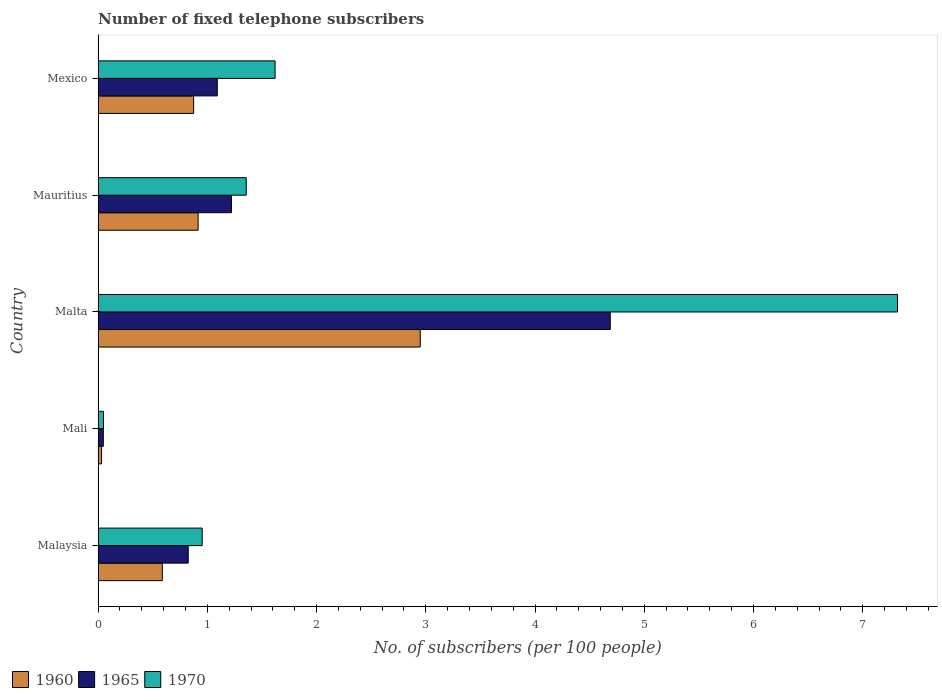Are the number of bars on each tick of the Y-axis equal?
Offer a terse response. Yes. How many bars are there on the 2nd tick from the top?
Make the answer very short. 3. How many bars are there on the 4th tick from the bottom?
Keep it short and to the point. 3. What is the label of the 3rd group of bars from the top?
Give a very brief answer. Malta. In how many cases, is the number of bars for a given country not equal to the number of legend labels?
Offer a terse response. 0. What is the number of fixed telephone subscribers in 1970 in Mauritius?
Offer a very short reply. 1.36. Across all countries, what is the maximum number of fixed telephone subscribers in 1970?
Offer a terse response. 7.32. Across all countries, what is the minimum number of fixed telephone subscribers in 1965?
Keep it short and to the point. 0.05. In which country was the number of fixed telephone subscribers in 1960 maximum?
Make the answer very short. Malta. In which country was the number of fixed telephone subscribers in 1970 minimum?
Your answer should be very brief. Mali. What is the total number of fixed telephone subscribers in 1965 in the graph?
Offer a terse response. 7.88. What is the difference between the number of fixed telephone subscribers in 1960 in Mali and that in Mauritius?
Offer a very short reply. -0.88. What is the difference between the number of fixed telephone subscribers in 1960 in Malaysia and the number of fixed telephone subscribers in 1965 in Mali?
Provide a short and direct response. 0.54. What is the average number of fixed telephone subscribers in 1960 per country?
Keep it short and to the point. 1.07. What is the difference between the number of fixed telephone subscribers in 1965 and number of fixed telephone subscribers in 1960 in Mexico?
Your answer should be very brief. 0.22. In how many countries, is the number of fixed telephone subscribers in 1965 greater than 3.2 ?
Ensure brevity in your answer.  1. What is the ratio of the number of fixed telephone subscribers in 1970 in Malaysia to that in Mali?
Make the answer very short. 19.1. Is the number of fixed telephone subscribers in 1965 in Mali less than that in Mexico?
Your response must be concise. Yes. What is the difference between the highest and the second highest number of fixed telephone subscribers in 1970?
Provide a short and direct response. 5.7. What is the difference between the highest and the lowest number of fixed telephone subscribers in 1970?
Keep it short and to the point. 7.27. What does the 1st bar from the bottom in Malaysia represents?
Make the answer very short. 1960. Is it the case that in every country, the sum of the number of fixed telephone subscribers in 1965 and number of fixed telephone subscribers in 1960 is greater than the number of fixed telephone subscribers in 1970?
Give a very brief answer. Yes. Are all the bars in the graph horizontal?
Your response must be concise. Yes. How many countries are there in the graph?
Make the answer very short. 5. What is the difference between two consecutive major ticks on the X-axis?
Keep it short and to the point. 1. Are the values on the major ticks of X-axis written in scientific E-notation?
Your answer should be very brief. No. Where does the legend appear in the graph?
Your answer should be very brief. Bottom left. What is the title of the graph?
Keep it short and to the point. Number of fixed telephone subscribers. Does "1989" appear as one of the legend labels in the graph?
Keep it short and to the point. No. What is the label or title of the X-axis?
Your answer should be compact. No. of subscribers (per 100 people). What is the label or title of the Y-axis?
Your response must be concise. Country. What is the No. of subscribers (per 100 people) in 1960 in Malaysia?
Give a very brief answer. 0.59. What is the No. of subscribers (per 100 people) in 1965 in Malaysia?
Offer a terse response. 0.83. What is the No. of subscribers (per 100 people) in 1970 in Malaysia?
Give a very brief answer. 0.95. What is the No. of subscribers (per 100 people) in 1960 in Mali?
Provide a short and direct response. 0.03. What is the No. of subscribers (per 100 people) in 1965 in Mali?
Make the answer very short. 0.05. What is the No. of subscribers (per 100 people) in 1970 in Mali?
Offer a very short reply. 0.05. What is the No. of subscribers (per 100 people) of 1960 in Malta?
Offer a very short reply. 2.95. What is the No. of subscribers (per 100 people) of 1965 in Malta?
Offer a very short reply. 4.69. What is the No. of subscribers (per 100 people) of 1970 in Malta?
Provide a short and direct response. 7.32. What is the No. of subscribers (per 100 people) in 1960 in Mauritius?
Your response must be concise. 0.92. What is the No. of subscribers (per 100 people) of 1965 in Mauritius?
Keep it short and to the point. 1.22. What is the No. of subscribers (per 100 people) of 1970 in Mauritius?
Your response must be concise. 1.36. What is the No. of subscribers (per 100 people) of 1960 in Mexico?
Your answer should be compact. 0.88. What is the No. of subscribers (per 100 people) of 1965 in Mexico?
Keep it short and to the point. 1.09. What is the No. of subscribers (per 100 people) in 1970 in Mexico?
Provide a succinct answer. 1.62. Across all countries, what is the maximum No. of subscribers (per 100 people) of 1960?
Provide a succinct answer. 2.95. Across all countries, what is the maximum No. of subscribers (per 100 people) in 1965?
Offer a terse response. 4.69. Across all countries, what is the maximum No. of subscribers (per 100 people) in 1970?
Offer a terse response. 7.32. Across all countries, what is the minimum No. of subscribers (per 100 people) of 1960?
Provide a short and direct response. 0.03. Across all countries, what is the minimum No. of subscribers (per 100 people) of 1965?
Make the answer very short. 0.05. Across all countries, what is the minimum No. of subscribers (per 100 people) in 1970?
Offer a very short reply. 0.05. What is the total No. of subscribers (per 100 people) in 1960 in the graph?
Keep it short and to the point. 5.36. What is the total No. of subscribers (per 100 people) in 1965 in the graph?
Your answer should be very brief. 7.88. What is the total No. of subscribers (per 100 people) in 1970 in the graph?
Provide a succinct answer. 11.3. What is the difference between the No. of subscribers (per 100 people) in 1960 in Malaysia and that in Mali?
Give a very brief answer. 0.56. What is the difference between the No. of subscribers (per 100 people) of 1965 in Malaysia and that in Mali?
Your answer should be very brief. 0.78. What is the difference between the No. of subscribers (per 100 people) of 1970 in Malaysia and that in Mali?
Offer a very short reply. 0.9. What is the difference between the No. of subscribers (per 100 people) of 1960 in Malaysia and that in Malta?
Give a very brief answer. -2.36. What is the difference between the No. of subscribers (per 100 people) of 1965 in Malaysia and that in Malta?
Provide a succinct answer. -3.86. What is the difference between the No. of subscribers (per 100 people) in 1970 in Malaysia and that in Malta?
Your answer should be very brief. -6.36. What is the difference between the No. of subscribers (per 100 people) in 1960 in Malaysia and that in Mauritius?
Keep it short and to the point. -0.33. What is the difference between the No. of subscribers (per 100 people) in 1965 in Malaysia and that in Mauritius?
Provide a short and direct response. -0.4. What is the difference between the No. of subscribers (per 100 people) of 1970 in Malaysia and that in Mauritius?
Ensure brevity in your answer.  -0.4. What is the difference between the No. of subscribers (per 100 people) in 1960 in Malaysia and that in Mexico?
Provide a short and direct response. -0.29. What is the difference between the No. of subscribers (per 100 people) in 1965 in Malaysia and that in Mexico?
Offer a very short reply. -0.27. What is the difference between the No. of subscribers (per 100 people) in 1970 in Malaysia and that in Mexico?
Offer a very short reply. -0.67. What is the difference between the No. of subscribers (per 100 people) in 1960 in Mali and that in Malta?
Give a very brief answer. -2.92. What is the difference between the No. of subscribers (per 100 people) of 1965 in Mali and that in Malta?
Keep it short and to the point. -4.64. What is the difference between the No. of subscribers (per 100 people) in 1970 in Mali and that in Malta?
Offer a very short reply. -7.27. What is the difference between the No. of subscribers (per 100 people) in 1960 in Mali and that in Mauritius?
Make the answer very short. -0.88. What is the difference between the No. of subscribers (per 100 people) of 1965 in Mali and that in Mauritius?
Ensure brevity in your answer.  -1.17. What is the difference between the No. of subscribers (per 100 people) of 1970 in Mali and that in Mauritius?
Offer a very short reply. -1.31. What is the difference between the No. of subscribers (per 100 people) in 1960 in Mali and that in Mexico?
Your answer should be compact. -0.84. What is the difference between the No. of subscribers (per 100 people) of 1965 in Mali and that in Mexico?
Offer a very short reply. -1.04. What is the difference between the No. of subscribers (per 100 people) in 1970 in Mali and that in Mexico?
Provide a succinct answer. -1.57. What is the difference between the No. of subscribers (per 100 people) in 1960 in Malta and that in Mauritius?
Make the answer very short. 2.03. What is the difference between the No. of subscribers (per 100 people) of 1965 in Malta and that in Mauritius?
Ensure brevity in your answer.  3.47. What is the difference between the No. of subscribers (per 100 people) of 1970 in Malta and that in Mauritius?
Ensure brevity in your answer.  5.96. What is the difference between the No. of subscribers (per 100 people) in 1960 in Malta and that in Mexico?
Your answer should be compact. 2.07. What is the difference between the No. of subscribers (per 100 people) in 1965 in Malta and that in Mexico?
Your answer should be very brief. 3.6. What is the difference between the No. of subscribers (per 100 people) in 1970 in Malta and that in Mexico?
Offer a very short reply. 5.7. What is the difference between the No. of subscribers (per 100 people) in 1960 in Mauritius and that in Mexico?
Keep it short and to the point. 0.04. What is the difference between the No. of subscribers (per 100 people) in 1965 in Mauritius and that in Mexico?
Your answer should be very brief. 0.13. What is the difference between the No. of subscribers (per 100 people) in 1970 in Mauritius and that in Mexico?
Your answer should be very brief. -0.26. What is the difference between the No. of subscribers (per 100 people) of 1960 in Malaysia and the No. of subscribers (per 100 people) of 1965 in Mali?
Offer a terse response. 0.54. What is the difference between the No. of subscribers (per 100 people) in 1960 in Malaysia and the No. of subscribers (per 100 people) in 1970 in Mali?
Provide a short and direct response. 0.54. What is the difference between the No. of subscribers (per 100 people) in 1965 in Malaysia and the No. of subscribers (per 100 people) in 1970 in Mali?
Keep it short and to the point. 0.78. What is the difference between the No. of subscribers (per 100 people) in 1960 in Malaysia and the No. of subscribers (per 100 people) in 1965 in Malta?
Ensure brevity in your answer.  -4.1. What is the difference between the No. of subscribers (per 100 people) in 1960 in Malaysia and the No. of subscribers (per 100 people) in 1970 in Malta?
Your answer should be very brief. -6.73. What is the difference between the No. of subscribers (per 100 people) in 1965 in Malaysia and the No. of subscribers (per 100 people) in 1970 in Malta?
Offer a very short reply. -6.49. What is the difference between the No. of subscribers (per 100 people) in 1960 in Malaysia and the No. of subscribers (per 100 people) in 1965 in Mauritius?
Your response must be concise. -0.63. What is the difference between the No. of subscribers (per 100 people) in 1960 in Malaysia and the No. of subscribers (per 100 people) in 1970 in Mauritius?
Offer a very short reply. -0.77. What is the difference between the No. of subscribers (per 100 people) of 1965 in Malaysia and the No. of subscribers (per 100 people) of 1970 in Mauritius?
Your response must be concise. -0.53. What is the difference between the No. of subscribers (per 100 people) of 1960 in Malaysia and the No. of subscribers (per 100 people) of 1965 in Mexico?
Your answer should be compact. -0.5. What is the difference between the No. of subscribers (per 100 people) in 1960 in Malaysia and the No. of subscribers (per 100 people) in 1970 in Mexico?
Give a very brief answer. -1.03. What is the difference between the No. of subscribers (per 100 people) in 1965 in Malaysia and the No. of subscribers (per 100 people) in 1970 in Mexico?
Provide a short and direct response. -0.8. What is the difference between the No. of subscribers (per 100 people) of 1960 in Mali and the No. of subscribers (per 100 people) of 1965 in Malta?
Offer a very short reply. -4.66. What is the difference between the No. of subscribers (per 100 people) in 1960 in Mali and the No. of subscribers (per 100 people) in 1970 in Malta?
Offer a very short reply. -7.29. What is the difference between the No. of subscribers (per 100 people) of 1965 in Mali and the No. of subscribers (per 100 people) of 1970 in Malta?
Provide a succinct answer. -7.27. What is the difference between the No. of subscribers (per 100 people) of 1960 in Mali and the No. of subscribers (per 100 people) of 1965 in Mauritius?
Give a very brief answer. -1.19. What is the difference between the No. of subscribers (per 100 people) of 1960 in Mali and the No. of subscribers (per 100 people) of 1970 in Mauritius?
Ensure brevity in your answer.  -1.32. What is the difference between the No. of subscribers (per 100 people) in 1965 in Mali and the No. of subscribers (per 100 people) in 1970 in Mauritius?
Make the answer very short. -1.31. What is the difference between the No. of subscribers (per 100 people) of 1960 in Mali and the No. of subscribers (per 100 people) of 1965 in Mexico?
Make the answer very short. -1.06. What is the difference between the No. of subscribers (per 100 people) of 1960 in Mali and the No. of subscribers (per 100 people) of 1970 in Mexico?
Provide a succinct answer. -1.59. What is the difference between the No. of subscribers (per 100 people) of 1965 in Mali and the No. of subscribers (per 100 people) of 1970 in Mexico?
Your response must be concise. -1.57. What is the difference between the No. of subscribers (per 100 people) in 1960 in Malta and the No. of subscribers (per 100 people) in 1965 in Mauritius?
Provide a succinct answer. 1.73. What is the difference between the No. of subscribers (per 100 people) in 1960 in Malta and the No. of subscribers (per 100 people) in 1970 in Mauritius?
Give a very brief answer. 1.59. What is the difference between the No. of subscribers (per 100 people) of 1965 in Malta and the No. of subscribers (per 100 people) of 1970 in Mauritius?
Make the answer very short. 3.33. What is the difference between the No. of subscribers (per 100 people) in 1960 in Malta and the No. of subscribers (per 100 people) in 1965 in Mexico?
Your answer should be compact. 1.86. What is the difference between the No. of subscribers (per 100 people) of 1960 in Malta and the No. of subscribers (per 100 people) of 1970 in Mexico?
Offer a terse response. 1.33. What is the difference between the No. of subscribers (per 100 people) in 1965 in Malta and the No. of subscribers (per 100 people) in 1970 in Mexico?
Your answer should be very brief. 3.07. What is the difference between the No. of subscribers (per 100 people) in 1960 in Mauritius and the No. of subscribers (per 100 people) in 1965 in Mexico?
Your answer should be very brief. -0.18. What is the difference between the No. of subscribers (per 100 people) of 1960 in Mauritius and the No. of subscribers (per 100 people) of 1970 in Mexico?
Your response must be concise. -0.7. What is the difference between the No. of subscribers (per 100 people) in 1965 in Mauritius and the No. of subscribers (per 100 people) in 1970 in Mexico?
Provide a short and direct response. -0.4. What is the average No. of subscribers (per 100 people) in 1960 per country?
Ensure brevity in your answer.  1.07. What is the average No. of subscribers (per 100 people) of 1965 per country?
Give a very brief answer. 1.58. What is the average No. of subscribers (per 100 people) of 1970 per country?
Your response must be concise. 2.26. What is the difference between the No. of subscribers (per 100 people) in 1960 and No. of subscribers (per 100 people) in 1965 in Malaysia?
Keep it short and to the point. -0.24. What is the difference between the No. of subscribers (per 100 people) in 1960 and No. of subscribers (per 100 people) in 1970 in Malaysia?
Provide a succinct answer. -0.36. What is the difference between the No. of subscribers (per 100 people) of 1965 and No. of subscribers (per 100 people) of 1970 in Malaysia?
Keep it short and to the point. -0.13. What is the difference between the No. of subscribers (per 100 people) in 1960 and No. of subscribers (per 100 people) in 1965 in Mali?
Give a very brief answer. -0.02. What is the difference between the No. of subscribers (per 100 people) in 1960 and No. of subscribers (per 100 people) in 1970 in Mali?
Make the answer very short. -0.02. What is the difference between the No. of subscribers (per 100 people) in 1965 and No. of subscribers (per 100 people) in 1970 in Mali?
Provide a succinct answer. -0. What is the difference between the No. of subscribers (per 100 people) in 1960 and No. of subscribers (per 100 people) in 1965 in Malta?
Keep it short and to the point. -1.74. What is the difference between the No. of subscribers (per 100 people) of 1960 and No. of subscribers (per 100 people) of 1970 in Malta?
Offer a very short reply. -4.37. What is the difference between the No. of subscribers (per 100 people) in 1965 and No. of subscribers (per 100 people) in 1970 in Malta?
Provide a short and direct response. -2.63. What is the difference between the No. of subscribers (per 100 people) of 1960 and No. of subscribers (per 100 people) of 1965 in Mauritius?
Offer a very short reply. -0.31. What is the difference between the No. of subscribers (per 100 people) in 1960 and No. of subscribers (per 100 people) in 1970 in Mauritius?
Keep it short and to the point. -0.44. What is the difference between the No. of subscribers (per 100 people) in 1965 and No. of subscribers (per 100 people) in 1970 in Mauritius?
Ensure brevity in your answer.  -0.14. What is the difference between the No. of subscribers (per 100 people) in 1960 and No. of subscribers (per 100 people) in 1965 in Mexico?
Your answer should be very brief. -0.22. What is the difference between the No. of subscribers (per 100 people) of 1960 and No. of subscribers (per 100 people) of 1970 in Mexico?
Your answer should be compact. -0.75. What is the difference between the No. of subscribers (per 100 people) in 1965 and No. of subscribers (per 100 people) in 1970 in Mexico?
Provide a succinct answer. -0.53. What is the ratio of the No. of subscribers (per 100 people) in 1960 in Malaysia to that in Mali?
Your answer should be compact. 18.21. What is the ratio of the No. of subscribers (per 100 people) in 1965 in Malaysia to that in Mali?
Give a very brief answer. 17.06. What is the ratio of the No. of subscribers (per 100 people) in 1970 in Malaysia to that in Mali?
Keep it short and to the point. 19.1. What is the ratio of the No. of subscribers (per 100 people) in 1960 in Malaysia to that in Malta?
Give a very brief answer. 0.2. What is the ratio of the No. of subscribers (per 100 people) of 1965 in Malaysia to that in Malta?
Offer a very short reply. 0.18. What is the ratio of the No. of subscribers (per 100 people) in 1970 in Malaysia to that in Malta?
Make the answer very short. 0.13. What is the ratio of the No. of subscribers (per 100 people) in 1960 in Malaysia to that in Mauritius?
Give a very brief answer. 0.64. What is the ratio of the No. of subscribers (per 100 people) in 1965 in Malaysia to that in Mauritius?
Offer a very short reply. 0.68. What is the ratio of the No. of subscribers (per 100 people) in 1970 in Malaysia to that in Mauritius?
Give a very brief answer. 0.7. What is the ratio of the No. of subscribers (per 100 people) in 1960 in Malaysia to that in Mexico?
Provide a succinct answer. 0.67. What is the ratio of the No. of subscribers (per 100 people) of 1965 in Malaysia to that in Mexico?
Your answer should be compact. 0.76. What is the ratio of the No. of subscribers (per 100 people) in 1970 in Malaysia to that in Mexico?
Make the answer very short. 0.59. What is the ratio of the No. of subscribers (per 100 people) of 1960 in Mali to that in Malta?
Provide a short and direct response. 0.01. What is the ratio of the No. of subscribers (per 100 people) in 1965 in Mali to that in Malta?
Give a very brief answer. 0.01. What is the ratio of the No. of subscribers (per 100 people) of 1970 in Mali to that in Malta?
Your response must be concise. 0.01. What is the ratio of the No. of subscribers (per 100 people) of 1960 in Mali to that in Mauritius?
Give a very brief answer. 0.04. What is the ratio of the No. of subscribers (per 100 people) of 1965 in Mali to that in Mauritius?
Ensure brevity in your answer.  0.04. What is the ratio of the No. of subscribers (per 100 people) of 1970 in Mali to that in Mauritius?
Give a very brief answer. 0.04. What is the ratio of the No. of subscribers (per 100 people) in 1960 in Mali to that in Mexico?
Give a very brief answer. 0.04. What is the ratio of the No. of subscribers (per 100 people) in 1965 in Mali to that in Mexico?
Ensure brevity in your answer.  0.04. What is the ratio of the No. of subscribers (per 100 people) in 1970 in Mali to that in Mexico?
Ensure brevity in your answer.  0.03. What is the ratio of the No. of subscribers (per 100 people) in 1960 in Malta to that in Mauritius?
Offer a very short reply. 3.22. What is the ratio of the No. of subscribers (per 100 people) in 1965 in Malta to that in Mauritius?
Provide a short and direct response. 3.84. What is the ratio of the No. of subscribers (per 100 people) in 1970 in Malta to that in Mauritius?
Make the answer very short. 5.39. What is the ratio of the No. of subscribers (per 100 people) of 1960 in Malta to that in Mexico?
Ensure brevity in your answer.  3.37. What is the ratio of the No. of subscribers (per 100 people) in 1965 in Malta to that in Mexico?
Offer a terse response. 4.3. What is the ratio of the No. of subscribers (per 100 people) in 1970 in Malta to that in Mexico?
Provide a succinct answer. 4.52. What is the ratio of the No. of subscribers (per 100 people) of 1960 in Mauritius to that in Mexico?
Make the answer very short. 1.05. What is the ratio of the No. of subscribers (per 100 people) of 1965 in Mauritius to that in Mexico?
Ensure brevity in your answer.  1.12. What is the ratio of the No. of subscribers (per 100 people) in 1970 in Mauritius to that in Mexico?
Your answer should be very brief. 0.84. What is the difference between the highest and the second highest No. of subscribers (per 100 people) of 1960?
Offer a very short reply. 2.03. What is the difference between the highest and the second highest No. of subscribers (per 100 people) in 1965?
Your answer should be very brief. 3.47. What is the difference between the highest and the second highest No. of subscribers (per 100 people) of 1970?
Offer a terse response. 5.7. What is the difference between the highest and the lowest No. of subscribers (per 100 people) in 1960?
Your response must be concise. 2.92. What is the difference between the highest and the lowest No. of subscribers (per 100 people) of 1965?
Provide a short and direct response. 4.64. What is the difference between the highest and the lowest No. of subscribers (per 100 people) in 1970?
Your answer should be compact. 7.27. 